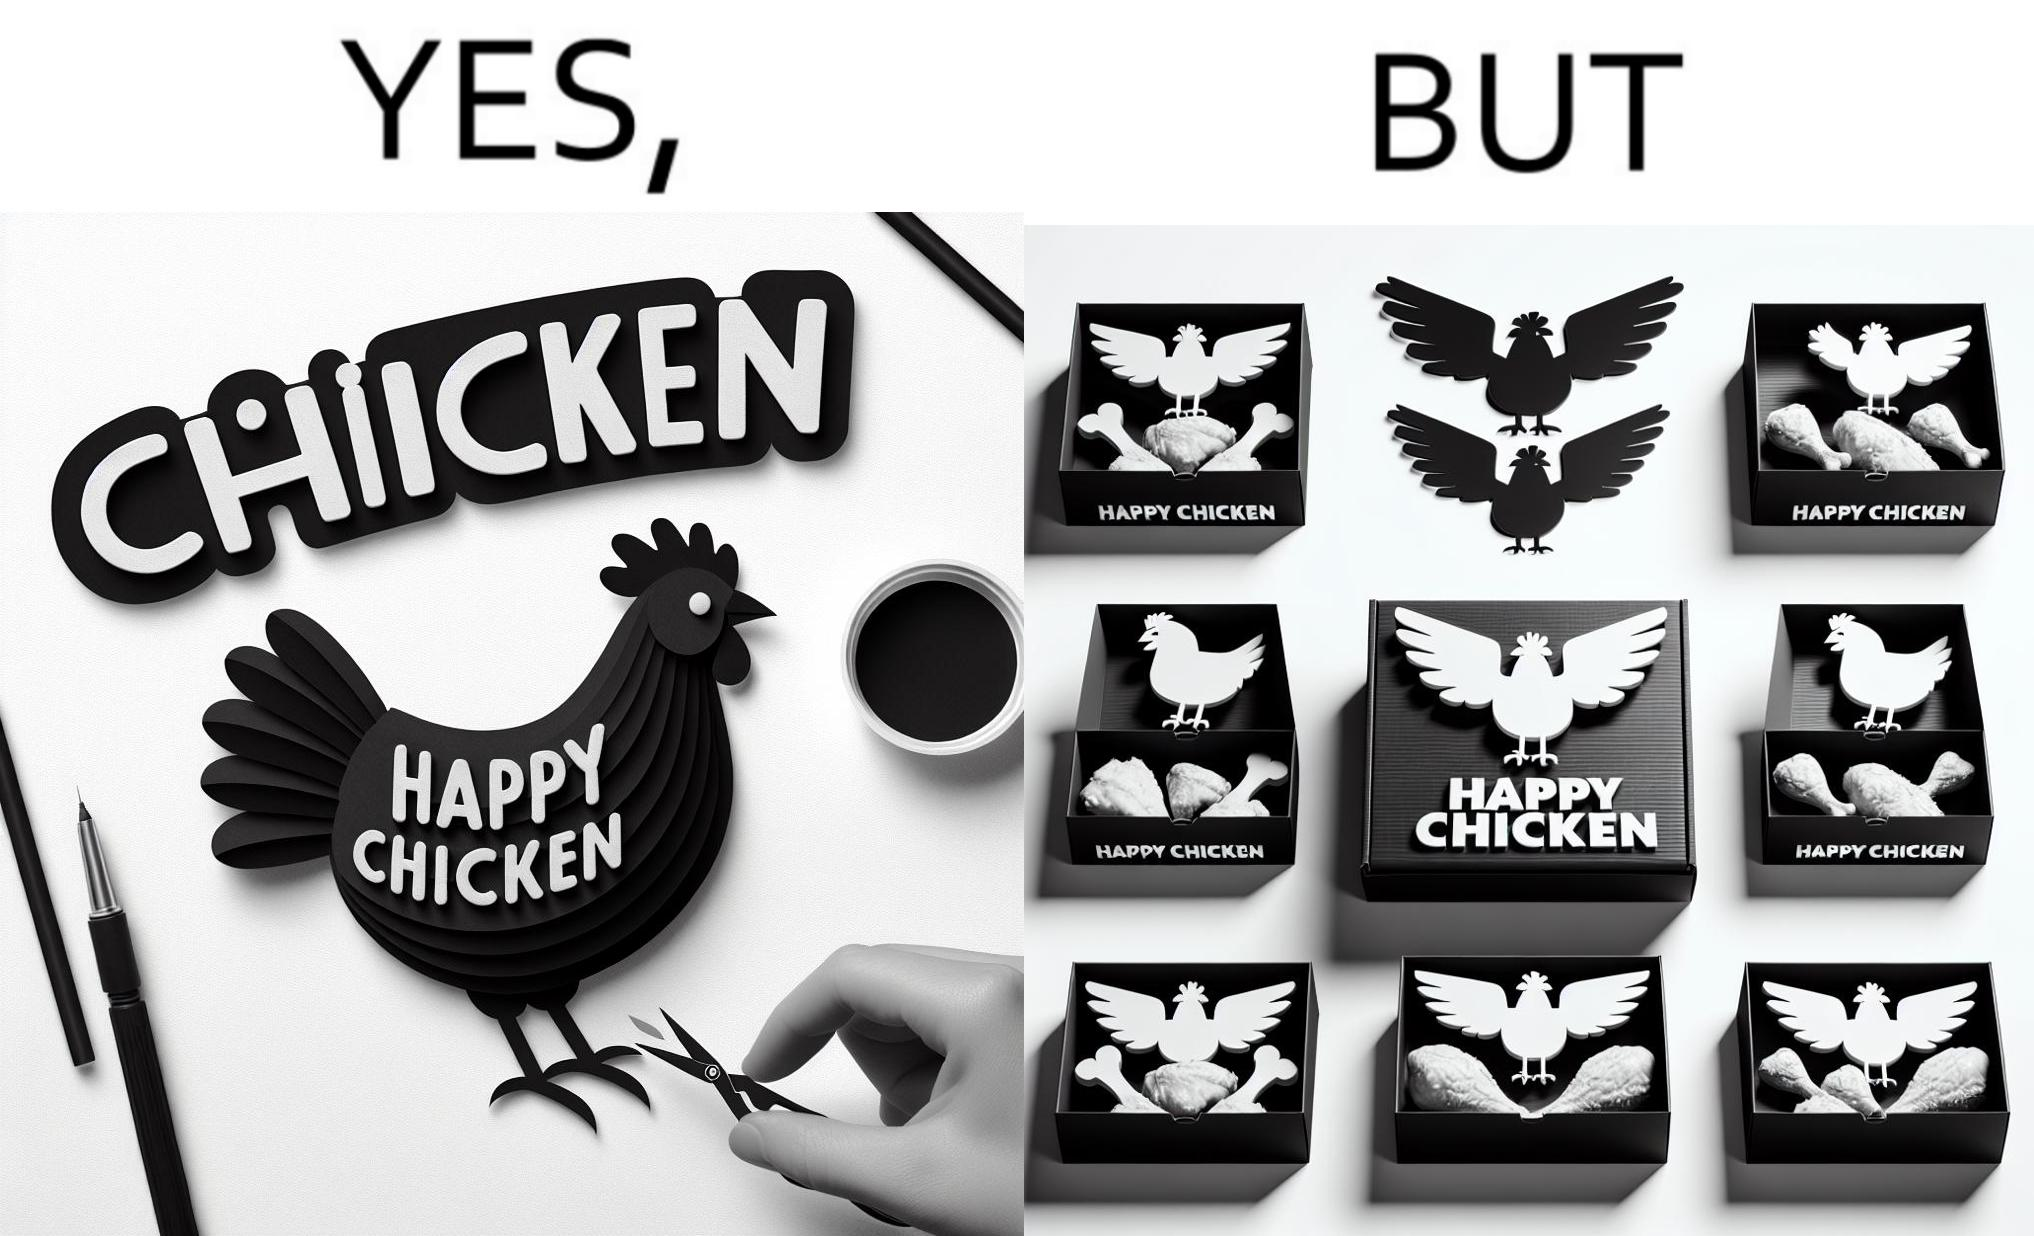Describe the content of this image. The image is ironic, because in the left image as in the logo it shows happy chicken but in the right image the chicken pieces are shown packed in boxes 